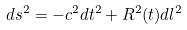Convert formula to latex. <formula><loc_0><loc_0><loc_500><loc_500>d s ^ { 2 } = - c ^ { 2 } d t ^ { 2 } + R ^ { 2 } ( t ) d l ^ { 2 }</formula> 